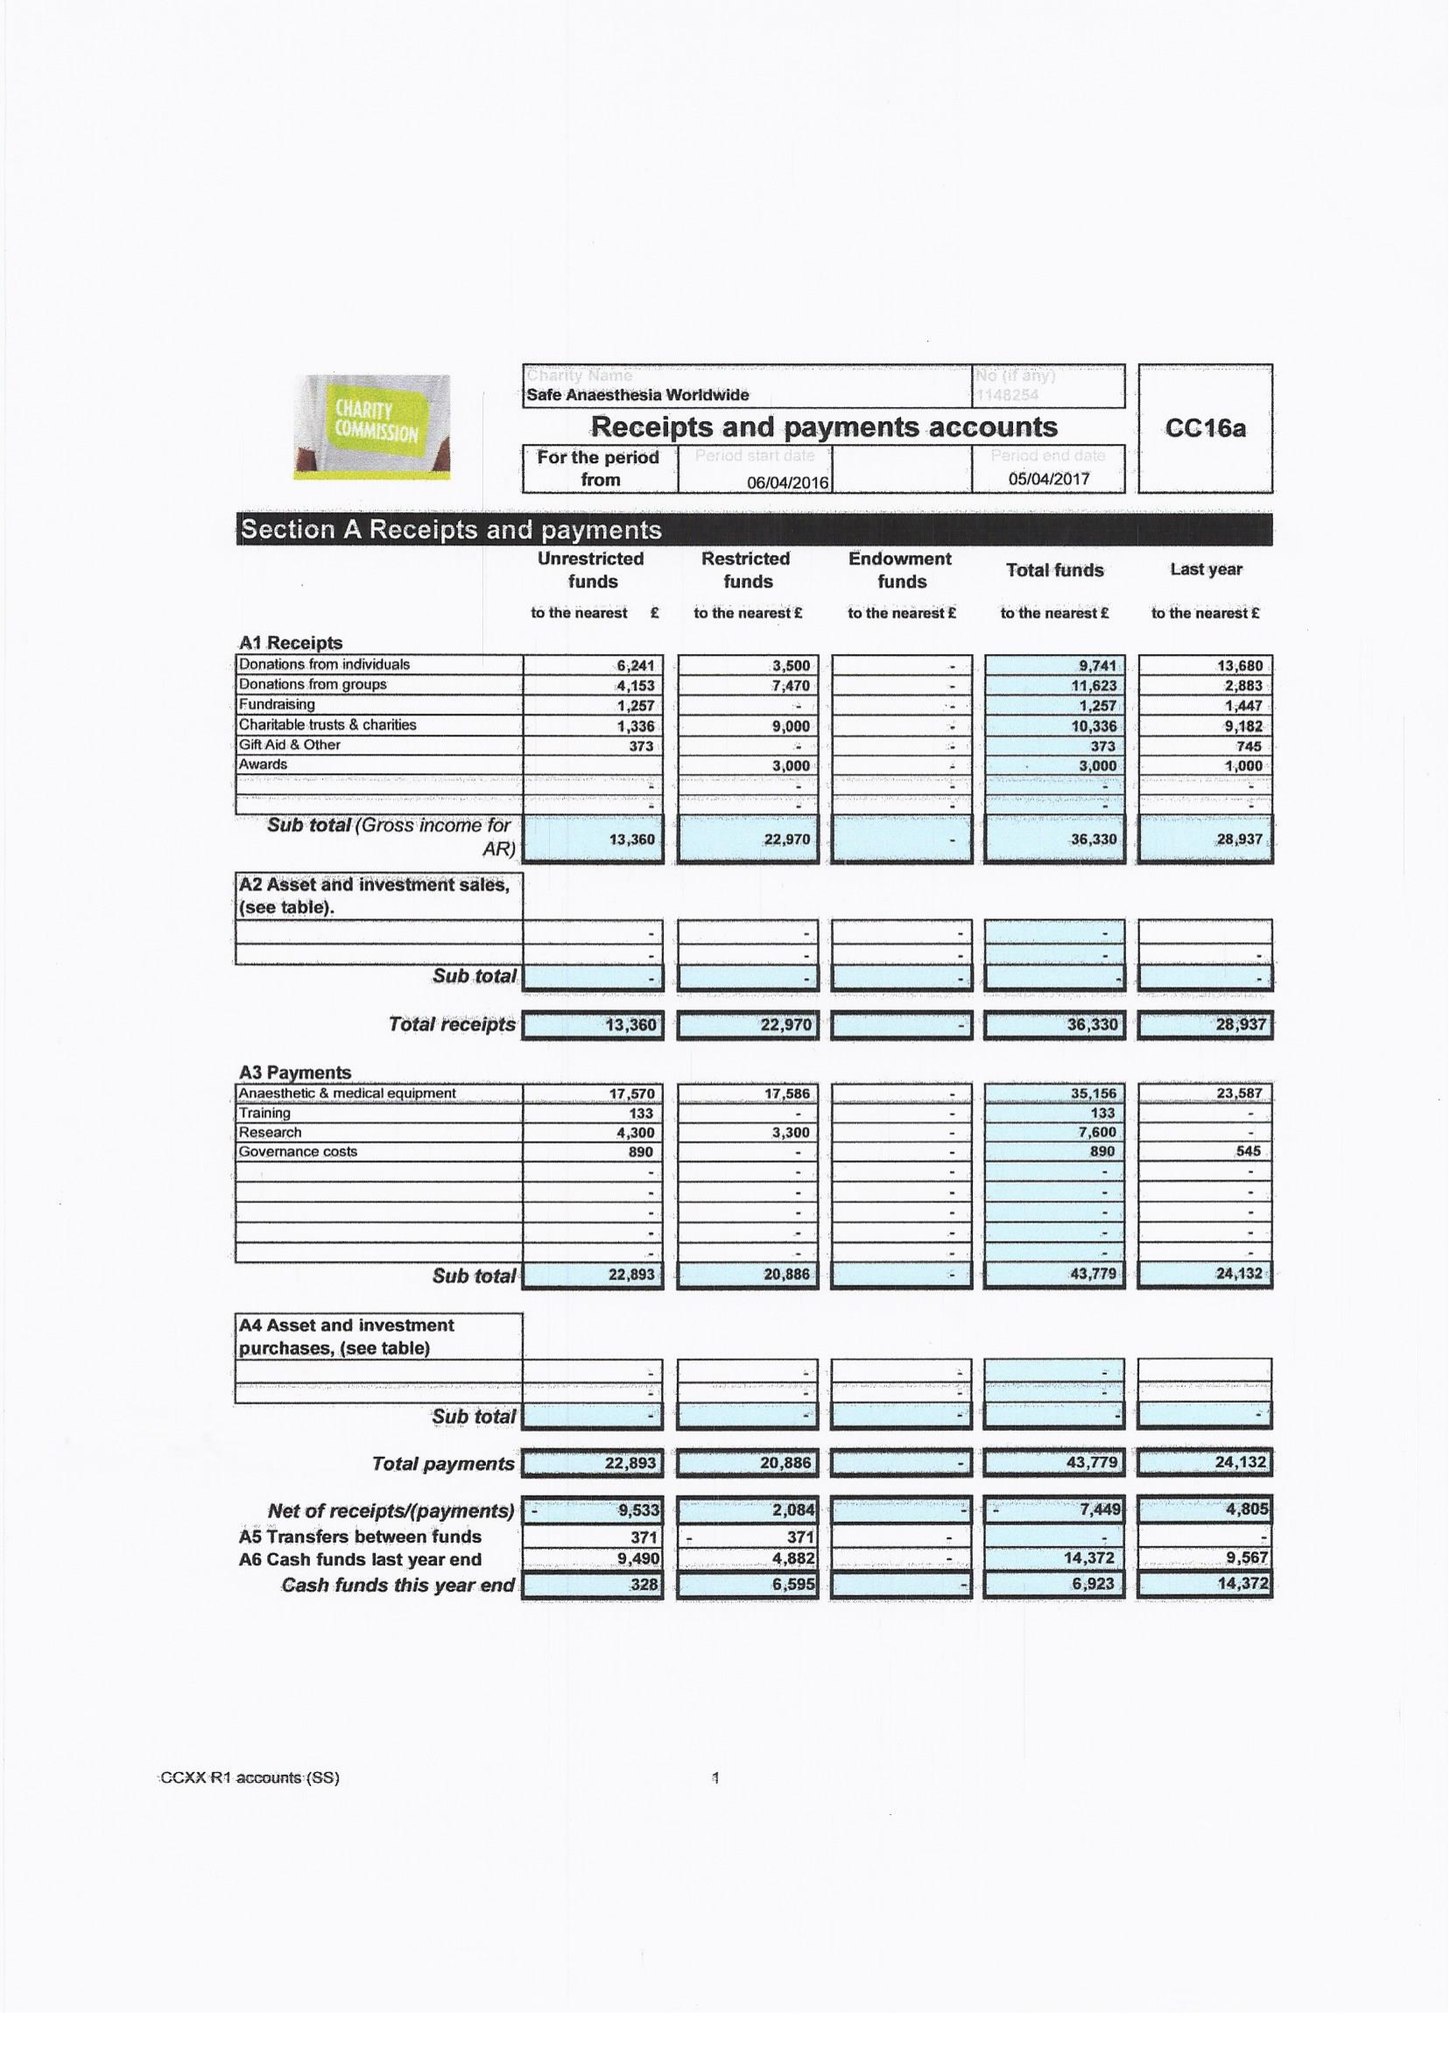What is the value for the address__street_line?
Answer the question using a single word or phrase. HIGH STREET 